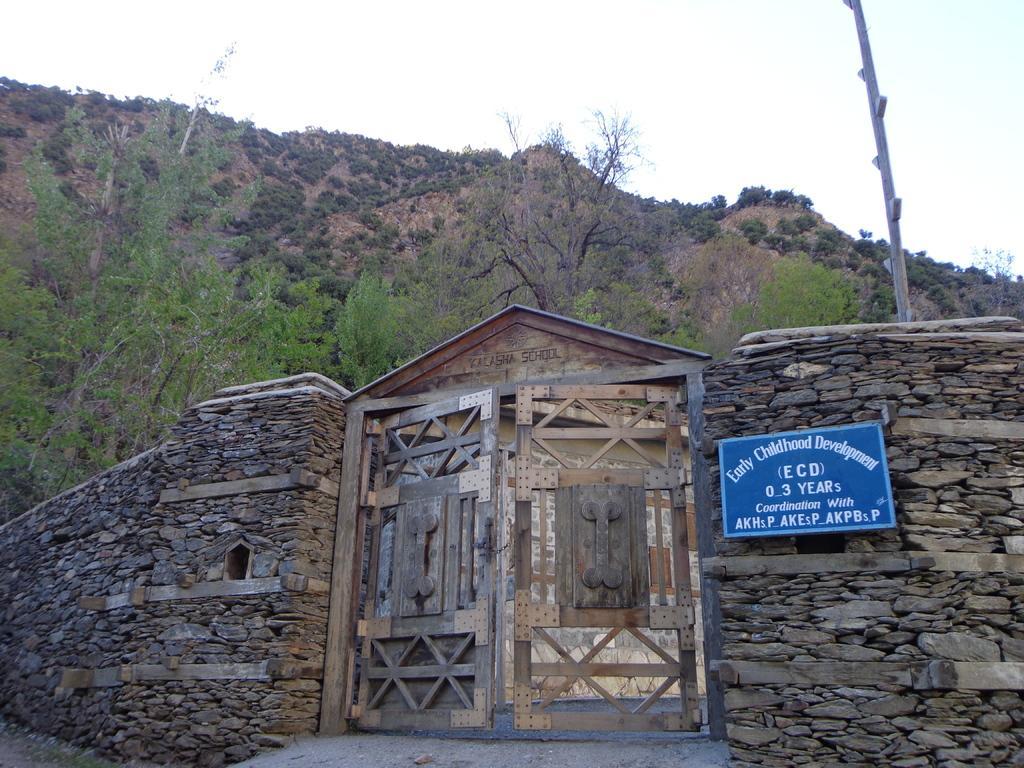Describe this image in one or two sentences. In the picture,there is an infant development school. It has wooden gates and beside the gates the wall is made up of stones and behind the school there is a mountain with a lot of trees. 